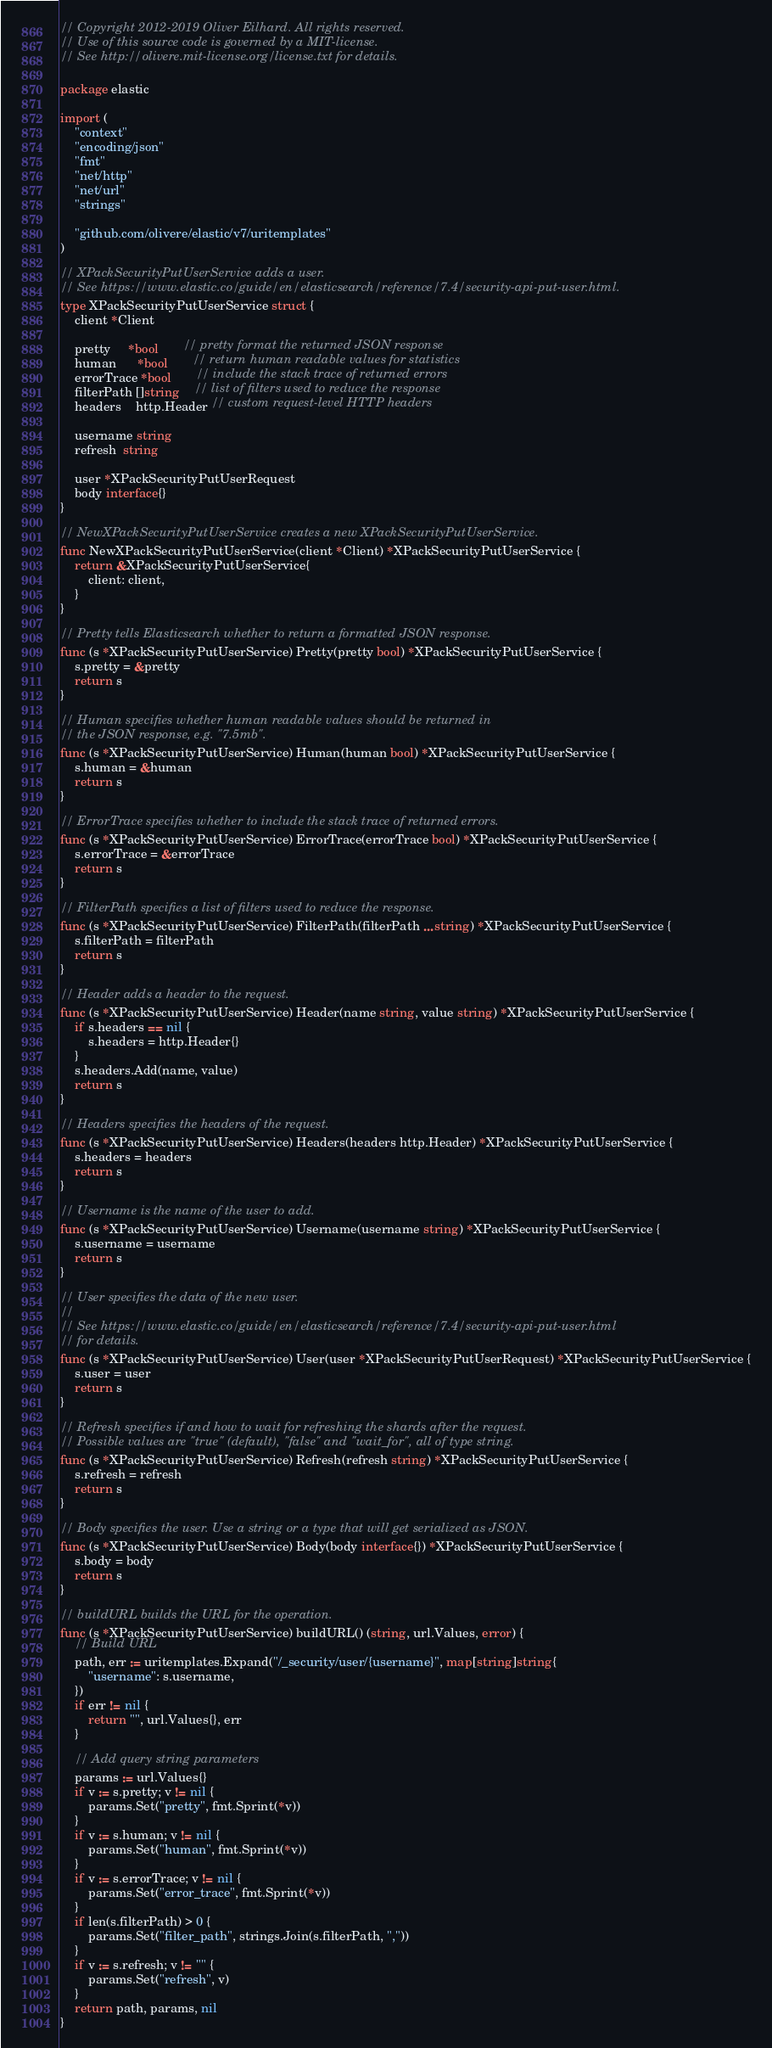Convert code to text. <code><loc_0><loc_0><loc_500><loc_500><_Go_>// Copyright 2012-2019 Oliver Eilhard. All rights reserved.
// Use of this source code is governed by a MIT-license.
// See http://olivere.mit-license.org/license.txt for details.

package elastic

import (
	"context"
	"encoding/json"
	"fmt"
	"net/http"
	"net/url"
	"strings"

	"github.com/olivere/elastic/v7/uritemplates"
)

// XPackSecurityPutUserService adds a user.
// See https://www.elastic.co/guide/en/elasticsearch/reference/7.4/security-api-put-user.html.
type XPackSecurityPutUserService struct {
	client *Client

	pretty     *bool       // pretty format the returned JSON response
	human      *bool       // return human readable values for statistics
	errorTrace *bool       // include the stack trace of returned errors
	filterPath []string    // list of filters used to reduce the response
	headers    http.Header // custom request-level HTTP headers

	username string
	refresh  string

	user *XPackSecurityPutUserRequest
	body interface{}
}

// NewXPackSecurityPutUserService creates a new XPackSecurityPutUserService.
func NewXPackSecurityPutUserService(client *Client) *XPackSecurityPutUserService {
	return &XPackSecurityPutUserService{
		client: client,
	}
}

// Pretty tells Elasticsearch whether to return a formatted JSON response.
func (s *XPackSecurityPutUserService) Pretty(pretty bool) *XPackSecurityPutUserService {
	s.pretty = &pretty
	return s
}

// Human specifies whether human readable values should be returned in
// the JSON response, e.g. "7.5mb".
func (s *XPackSecurityPutUserService) Human(human bool) *XPackSecurityPutUserService {
	s.human = &human
	return s
}

// ErrorTrace specifies whether to include the stack trace of returned errors.
func (s *XPackSecurityPutUserService) ErrorTrace(errorTrace bool) *XPackSecurityPutUserService {
	s.errorTrace = &errorTrace
	return s
}

// FilterPath specifies a list of filters used to reduce the response.
func (s *XPackSecurityPutUserService) FilterPath(filterPath ...string) *XPackSecurityPutUserService {
	s.filterPath = filterPath
	return s
}

// Header adds a header to the request.
func (s *XPackSecurityPutUserService) Header(name string, value string) *XPackSecurityPutUserService {
	if s.headers == nil {
		s.headers = http.Header{}
	}
	s.headers.Add(name, value)
	return s
}

// Headers specifies the headers of the request.
func (s *XPackSecurityPutUserService) Headers(headers http.Header) *XPackSecurityPutUserService {
	s.headers = headers
	return s
}

// Username is the name of the user to add.
func (s *XPackSecurityPutUserService) Username(username string) *XPackSecurityPutUserService {
	s.username = username
	return s
}

// User specifies the data of the new user.
//
// See https://www.elastic.co/guide/en/elasticsearch/reference/7.4/security-api-put-user.html
// for details.
func (s *XPackSecurityPutUserService) User(user *XPackSecurityPutUserRequest) *XPackSecurityPutUserService {
	s.user = user
	return s
}

// Refresh specifies if and how to wait for refreshing the shards after the request.
// Possible values are "true" (default), "false" and "wait_for", all of type string.
func (s *XPackSecurityPutUserService) Refresh(refresh string) *XPackSecurityPutUserService {
	s.refresh = refresh
	return s
}

// Body specifies the user. Use a string or a type that will get serialized as JSON.
func (s *XPackSecurityPutUserService) Body(body interface{}) *XPackSecurityPutUserService {
	s.body = body
	return s
}

// buildURL builds the URL for the operation.
func (s *XPackSecurityPutUserService) buildURL() (string, url.Values, error) {
	// Build URL
	path, err := uritemplates.Expand("/_security/user/{username}", map[string]string{
		"username": s.username,
	})
	if err != nil {
		return "", url.Values{}, err
	}

	// Add query string parameters
	params := url.Values{}
	if v := s.pretty; v != nil {
		params.Set("pretty", fmt.Sprint(*v))
	}
	if v := s.human; v != nil {
		params.Set("human", fmt.Sprint(*v))
	}
	if v := s.errorTrace; v != nil {
		params.Set("error_trace", fmt.Sprint(*v))
	}
	if len(s.filterPath) > 0 {
		params.Set("filter_path", strings.Join(s.filterPath, ","))
	}
	if v := s.refresh; v != "" {
		params.Set("refresh", v)
	}
	return path, params, nil
}
</code> 